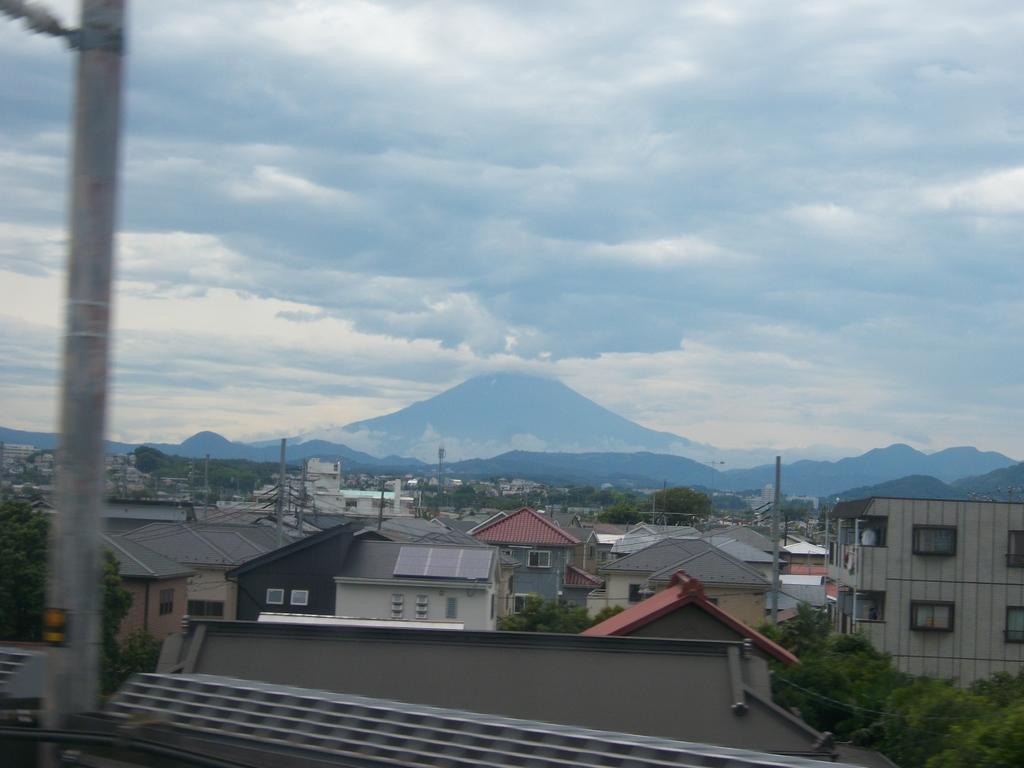How would you summarize this image in a sentence or two? In this image we can see few buildings, poles, trees, mountains and the sky with clouds in the background. 